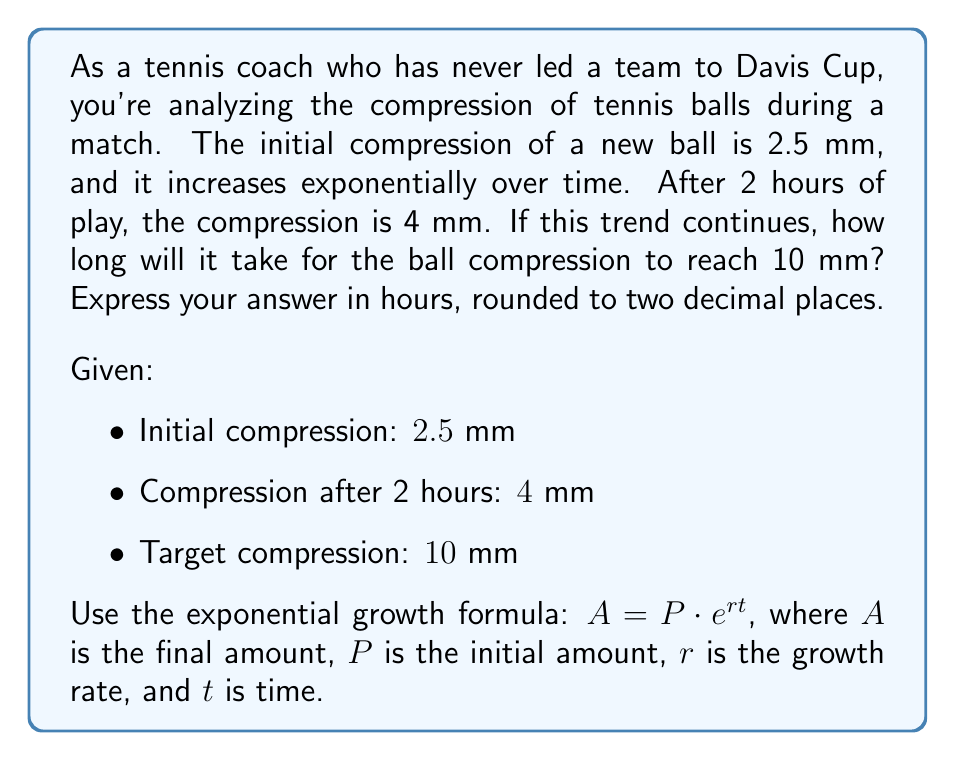Can you solve this math problem? Let's approach this step-by-step:

1) We'll use the exponential growth formula: $A = P \cdot e^{rt}$

2) First, we need to find the growth rate $r$ using the given information:
   $4 = 2.5 \cdot e^{r \cdot 2}$

3) Dividing both sides by 2.5:
   $\frac{4}{2.5} = e^{2r}$
   $1.6 = e^{2r}$

4) Taking the natural log of both sides:
   $\ln(1.6) = 2r$

5) Solving for $r$:
   $r = \frac{\ln(1.6)}{2} \approx 0.2345$

6) Now that we have $r$, we can use the formula to find $t$ when the compression reaches 10 mm:
   $10 = 2.5 \cdot e^{0.2345t}$

7) Dividing both sides by 2.5:
   $4 = e^{0.2345t}$

8) Taking the natural log of both sides:
   $\ln(4) = 0.2345t$

9) Solving for $t$:
   $t = \frac{\ln(4)}{0.2345} \approx 5.8979$ hours

10) Rounding to two decimal places: $5.90$ hours
Answer: $5.90$ hours 